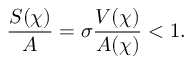<formula> <loc_0><loc_0><loc_500><loc_500>\frac { S ( \chi ) } { A } = \sigma \frac { V ( \chi ) } { A ( \chi ) } < 1 .</formula> 